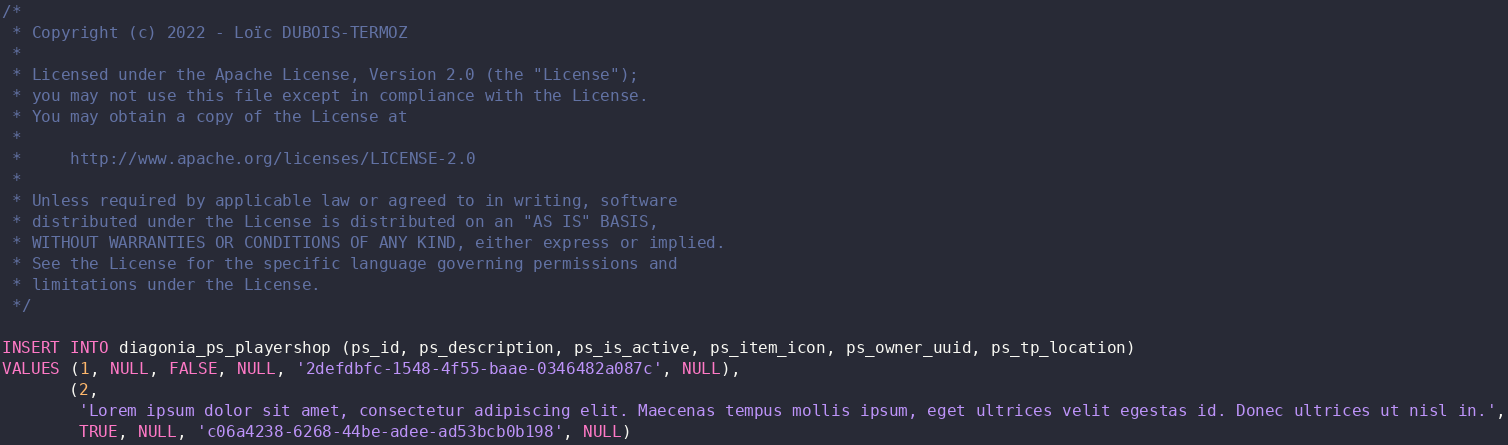<code> <loc_0><loc_0><loc_500><loc_500><_SQL_>/*
 * Copyright (c) 2022 - Loïc DUBOIS-TERMOZ
 *
 * Licensed under the Apache License, Version 2.0 (the "License");
 * you may not use this file except in compliance with the License.
 * You may obtain a copy of the License at
 *
 *     http://www.apache.org/licenses/LICENSE-2.0
 *
 * Unless required by applicable law or agreed to in writing, software
 * distributed under the License is distributed on an "AS IS" BASIS,
 * WITHOUT WARRANTIES OR CONDITIONS OF ANY KIND, either express or implied.
 * See the License for the specific language governing permissions and
 * limitations under the License.
 */

INSERT INTO diagonia_ps_playershop (ps_id, ps_description, ps_is_active, ps_item_icon, ps_owner_uuid, ps_tp_location)
VALUES (1, NULL, FALSE, NULL, '2defdbfc-1548-4f55-baae-0346482a087c', NULL),
       (2,
        'Lorem ipsum dolor sit amet, consectetur adipiscing elit. Maecenas tempus mollis ipsum, eget ultrices velit egestas id. Donec ultrices ut nisl in.',
        TRUE, NULL, 'c06a4238-6268-44be-adee-ad53bcb0b198', NULL)
</code> 